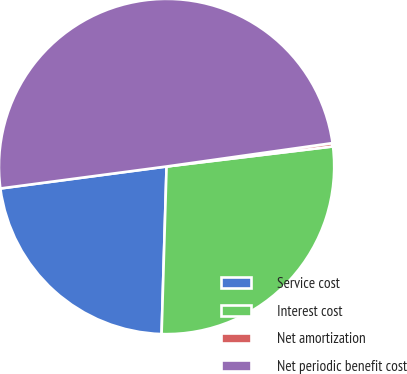<chart> <loc_0><loc_0><loc_500><loc_500><pie_chart><fcel>Service cost<fcel>Interest cost<fcel>Net amortization<fcel>Net periodic benefit cost<nl><fcel>22.43%<fcel>27.38%<fcel>0.32%<fcel>49.86%<nl></chart> 